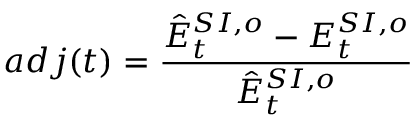Convert formula to latex. <formula><loc_0><loc_0><loc_500><loc_500>a d j ( t ) = \frac { \hat { E } _ { t } ^ { S I , o } - E _ { t } ^ { S I , o } } { \hat { E } _ { t } ^ { S I , o } }</formula> 